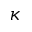<formula> <loc_0><loc_0><loc_500><loc_500>\kappa</formula> 